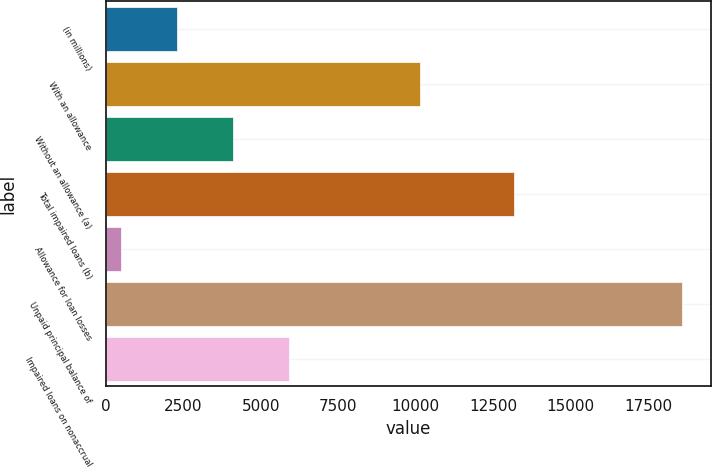<chart> <loc_0><loc_0><loc_500><loc_500><bar_chart><fcel>(in millions)<fcel>With an allowance<fcel>Without an allowance (a)<fcel>Total impaired loans (b)<fcel>Allowance for loan losses<fcel>Unpaid principal balance of<fcel>Impaired loans on nonaccrual<nl><fcel>2303.7<fcel>10154<fcel>4113.4<fcel>13167<fcel>494<fcel>18591<fcel>5923.1<nl></chart> 